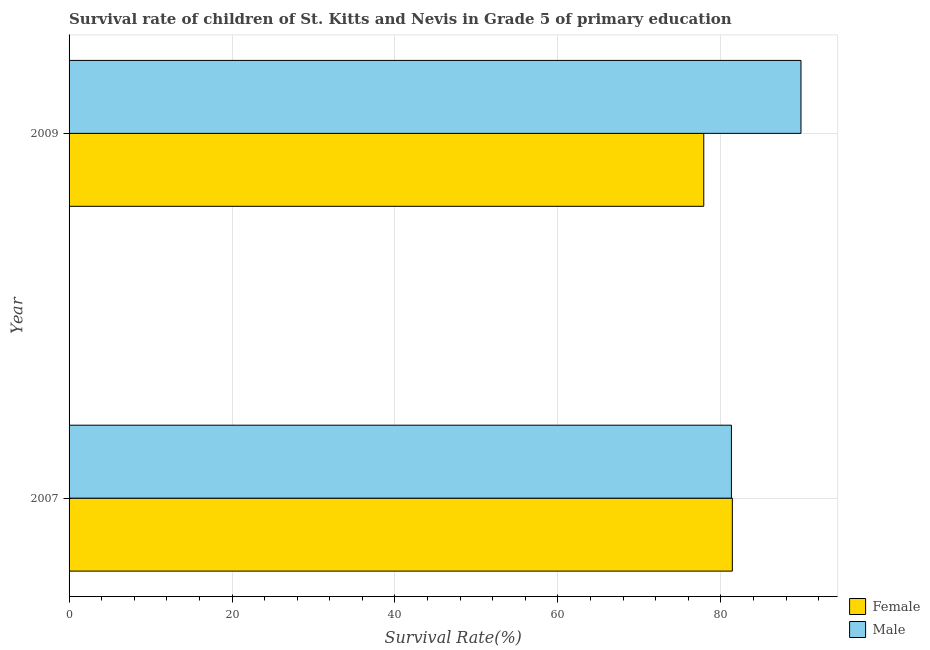How many different coloured bars are there?
Your response must be concise. 2. How many groups of bars are there?
Give a very brief answer. 2. Are the number of bars per tick equal to the number of legend labels?
Make the answer very short. Yes. How many bars are there on the 2nd tick from the top?
Make the answer very short. 2. What is the label of the 1st group of bars from the top?
Provide a short and direct response. 2009. What is the survival rate of female students in primary education in 2007?
Provide a succinct answer. 81.41. Across all years, what is the maximum survival rate of male students in primary education?
Provide a short and direct response. 89.83. Across all years, what is the minimum survival rate of male students in primary education?
Ensure brevity in your answer.  81.3. In which year was the survival rate of male students in primary education maximum?
Provide a short and direct response. 2009. In which year was the survival rate of female students in primary education minimum?
Offer a terse response. 2009. What is the total survival rate of female students in primary education in the graph?
Your answer should be very brief. 159.31. What is the difference between the survival rate of female students in primary education in 2007 and that in 2009?
Your response must be concise. 3.51. What is the difference between the survival rate of male students in primary education in 2009 and the survival rate of female students in primary education in 2007?
Your answer should be compact. 8.43. What is the average survival rate of male students in primary education per year?
Make the answer very short. 85.56. In the year 2009, what is the difference between the survival rate of male students in primary education and survival rate of female students in primary education?
Ensure brevity in your answer.  11.93. In how many years, is the survival rate of female students in primary education greater than 20 %?
Give a very brief answer. 2. What is the ratio of the survival rate of female students in primary education in 2007 to that in 2009?
Your answer should be very brief. 1.04. Is the survival rate of male students in primary education in 2007 less than that in 2009?
Your answer should be very brief. Yes. Is the difference between the survival rate of male students in primary education in 2007 and 2009 greater than the difference between the survival rate of female students in primary education in 2007 and 2009?
Provide a short and direct response. No. In how many years, is the survival rate of female students in primary education greater than the average survival rate of female students in primary education taken over all years?
Make the answer very short. 1. What does the 1st bar from the top in 2007 represents?
Offer a terse response. Male. What does the 2nd bar from the bottom in 2007 represents?
Your answer should be very brief. Male. How many bars are there?
Give a very brief answer. 4. What is the difference between two consecutive major ticks on the X-axis?
Keep it short and to the point. 20. Does the graph contain any zero values?
Offer a very short reply. No. Does the graph contain grids?
Keep it short and to the point. Yes. How many legend labels are there?
Your response must be concise. 2. What is the title of the graph?
Provide a short and direct response. Survival rate of children of St. Kitts and Nevis in Grade 5 of primary education. What is the label or title of the X-axis?
Keep it short and to the point. Survival Rate(%). What is the label or title of the Y-axis?
Ensure brevity in your answer.  Year. What is the Survival Rate(%) of Female in 2007?
Offer a very short reply. 81.41. What is the Survival Rate(%) in Male in 2007?
Make the answer very short. 81.3. What is the Survival Rate(%) in Female in 2009?
Give a very brief answer. 77.9. What is the Survival Rate(%) of Male in 2009?
Offer a terse response. 89.83. Across all years, what is the maximum Survival Rate(%) of Female?
Your answer should be compact. 81.41. Across all years, what is the maximum Survival Rate(%) of Male?
Provide a succinct answer. 89.83. Across all years, what is the minimum Survival Rate(%) in Female?
Provide a succinct answer. 77.9. Across all years, what is the minimum Survival Rate(%) of Male?
Ensure brevity in your answer.  81.3. What is the total Survival Rate(%) in Female in the graph?
Keep it short and to the point. 159.31. What is the total Survival Rate(%) in Male in the graph?
Provide a short and direct response. 171.13. What is the difference between the Survival Rate(%) of Female in 2007 and that in 2009?
Give a very brief answer. 3.51. What is the difference between the Survival Rate(%) of Male in 2007 and that in 2009?
Ensure brevity in your answer.  -8.54. What is the difference between the Survival Rate(%) of Female in 2007 and the Survival Rate(%) of Male in 2009?
Your answer should be very brief. -8.43. What is the average Survival Rate(%) in Female per year?
Your answer should be compact. 79.66. What is the average Survival Rate(%) of Male per year?
Your answer should be compact. 85.57. In the year 2007, what is the difference between the Survival Rate(%) of Female and Survival Rate(%) of Male?
Ensure brevity in your answer.  0.11. In the year 2009, what is the difference between the Survival Rate(%) of Female and Survival Rate(%) of Male?
Your answer should be compact. -11.93. What is the ratio of the Survival Rate(%) in Female in 2007 to that in 2009?
Keep it short and to the point. 1.04. What is the ratio of the Survival Rate(%) of Male in 2007 to that in 2009?
Provide a short and direct response. 0.9. What is the difference between the highest and the second highest Survival Rate(%) of Female?
Your response must be concise. 3.51. What is the difference between the highest and the second highest Survival Rate(%) in Male?
Provide a short and direct response. 8.54. What is the difference between the highest and the lowest Survival Rate(%) of Female?
Your answer should be very brief. 3.51. What is the difference between the highest and the lowest Survival Rate(%) of Male?
Your answer should be compact. 8.54. 